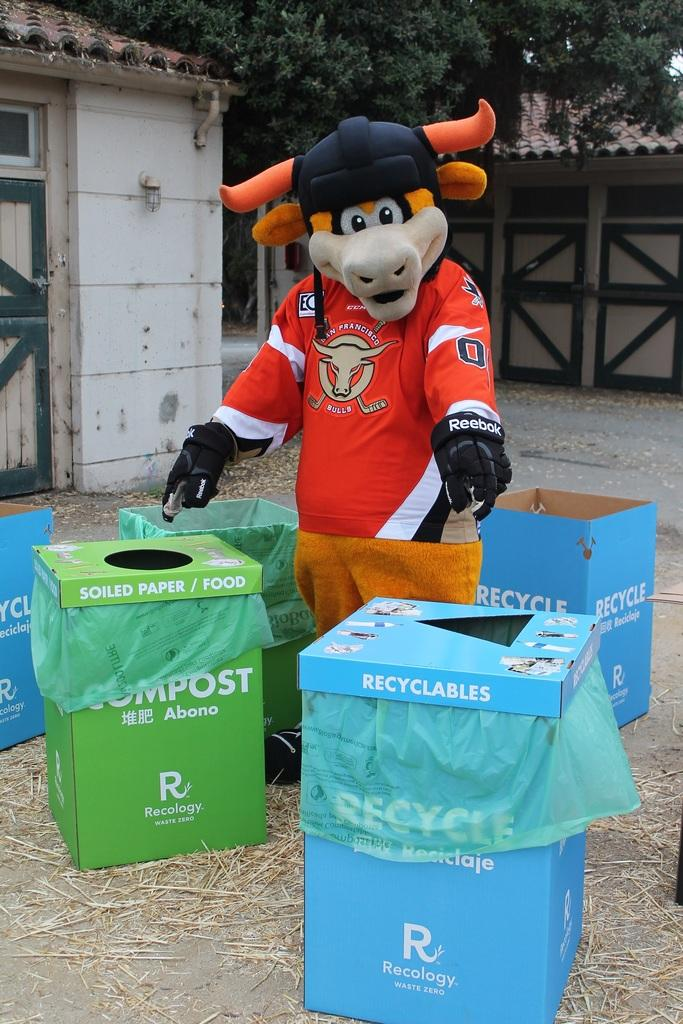<image>
Provide a brief description of the given image. Many different recycling bins both green and blue 